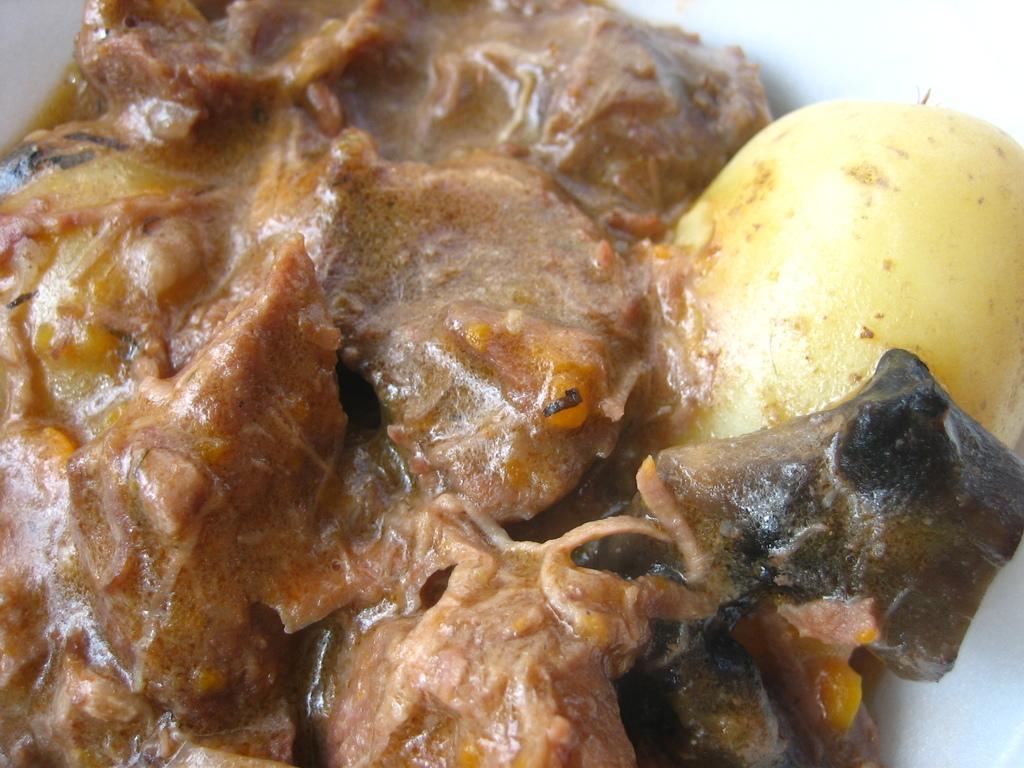Describe this image in one or two sentences. In this image we can see food item. 